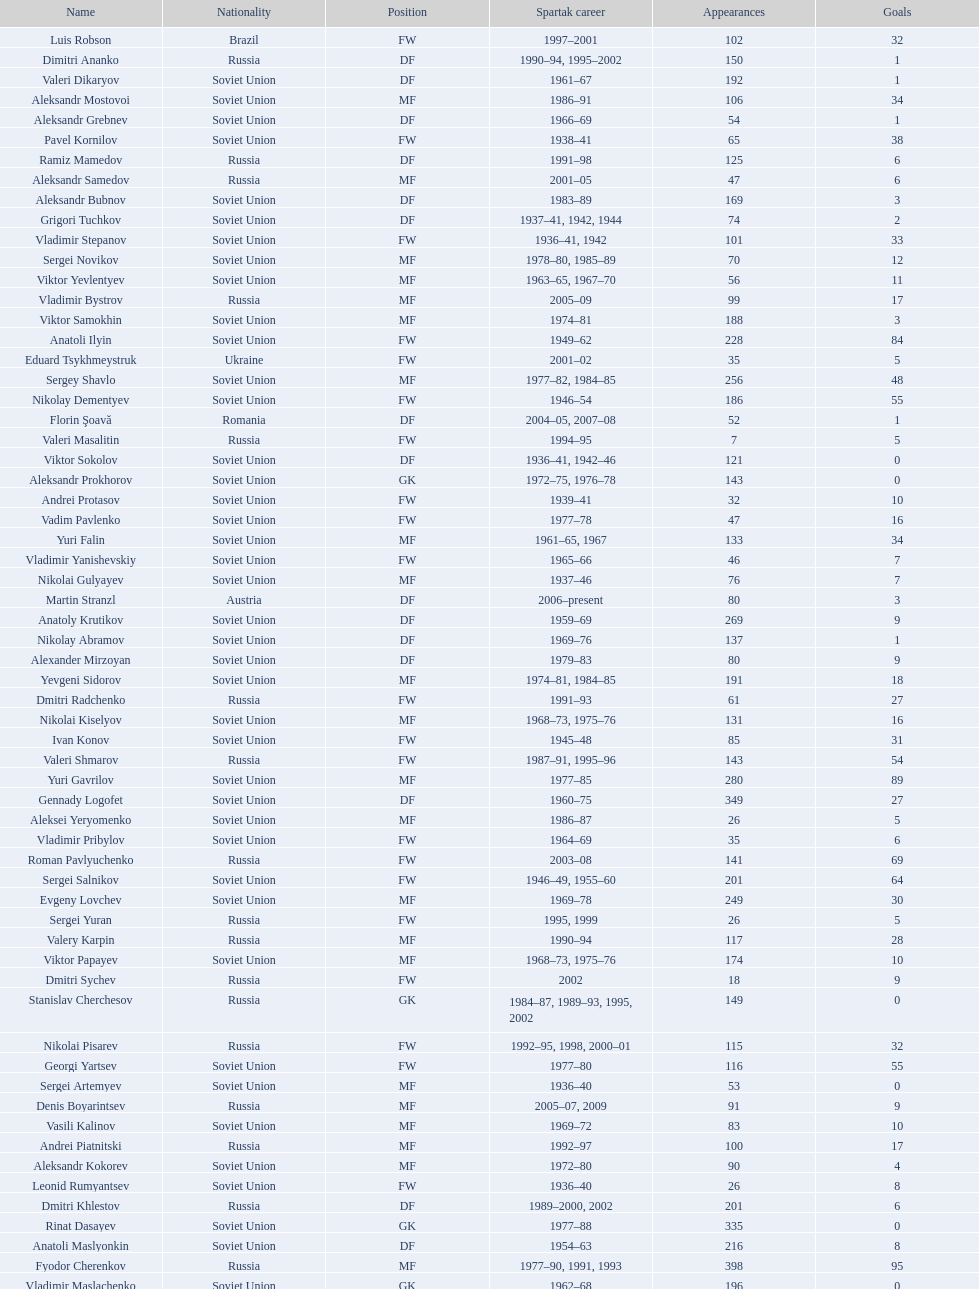Would you mind parsing the complete table? {'header': ['Name', 'Nationality', 'Position', 'Spartak career', 'Appearances', 'Goals'], 'rows': [['Luis Robson', 'Brazil', 'FW', '1997–2001', '102', '32'], ['Dimitri Ananko', 'Russia', 'DF', '1990–94, 1995–2002', '150', '1'], ['Valeri Dikaryov', 'Soviet Union', 'DF', '1961–67', '192', '1'], ['Aleksandr Mostovoi', 'Soviet Union', 'MF', '1986–91', '106', '34'], ['Aleksandr Grebnev', 'Soviet Union', 'DF', '1966–69', '54', '1'], ['Pavel Kornilov', 'Soviet Union', 'FW', '1938–41', '65', '38'], ['Ramiz Mamedov', 'Russia', 'DF', '1991–98', '125', '6'], ['Aleksandr Samedov', 'Russia', 'MF', '2001–05', '47', '6'], ['Aleksandr Bubnov', 'Soviet Union', 'DF', '1983–89', '169', '3'], ['Grigori Tuchkov', 'Soviet Union', 'DF', '1937–41, 1942, 1944', '74', '2'], ['Vladimir Stepanov', 'Soviet Union', 'FW', '1936–41, 1942', '101', '33'], ['Sergei Novikov', 'Soviet Union', 'MF', '1978–80, 1985–89', '70', '12'], ['Viktor Yevlentyev', 'Soviet Union', 'MF', '1963–65, 1967–70', '56', '11'], ['Vladimir Bystrov', 'Russia', 'MF', '2005–09', '99', '17'], ['Viktor Samokhin', 'Soviet Union', 'MF', '1974–81', '188', '3'], ['Anatoli Ilyin', 'Soviet Union', 'FW', '1949–62', '228', '84'], ['Eduard Tsykhmeystruk', 'Ukraine', 'FW', '2001–02', '35', '5'], ['Sergey Shavlo', 'Soviet Union', 'MF', '1977–82, 1984–85', '256', '48'], ['Nikolay Dementyev', 'Soviet Union', 'FW', '1946–54', '186', '55'], ['Florin Şoavă', 'Romania', 'DF', '2004–05, 2007–08', '52', '1'], ['Valeri Masalitin', 'Russia', 'FW', '1994–95', '7', '5'], ['Viktor Sokolov', 'Soviet Union', 'DF', '1936–41, 1942–46', '121', '0'], ['Aleksandr Prokhorov', 'Soviet Union', 'GK', '1972–75, 1976–78', '143', '0'], ['Andrei Protasov', 'Soviet Union', 'FW', '1939–41', '32', '10'], ['Vadim Pavlenko', 'Soviet Union', 'FW', '1977–78', '47', '16'], ['Yuri Falin', 'Soviet Union', 'MF', '1961–65, 1967', '133', '34'], ['Vladimir Yanishevskiy', 'Soviet Union', 'FW', '1965–66', '46', '7'], ['Nikolai Gulyayev', 'Soviet Union', 'MF', '1937–46', '76', '7'], ['Martin Stranzl', 'Austria', 'DF', '2006–present', '80', '3'], ['Anatoly Krutikov', 'Soviet Union', 'DF', '1959–69', '269', '9'], ['Nikolay Abramov', 'Soviet Union', 'DF', '1969–76', '137', '1'], ['Alexander Mirzoyan', 'Soviet Union', 'DF', '1979–83', '80', '9'], ['Yevgeni Sidorov', 'Soviet Union', 'MF', '1974–81, 1984–85', '191', '18'], ['Dmitri Radchenko', 'Russia', 'FW', '1991–93', '61', '27'], ['Nikolai Kiselyov', 'Soviet Union', 'MF', '1968–73, 1975–76', '131', '16'], ['Ivan Konov', 'Soviet Union', 'FW', '1945–48', '85', '31'], ['Valeri Shmarov', 'Russia', 'FW', '1987–91, 1995–96', '143', '54'], ['Yuri Gavrilov', 'Soviet Union', 'MF', '1977–85', '280', '89'], ['Gennady Logofet', 'Soviet Union', 'DF', '1960–75', '349', '27'], ['Aleksei Yeryomenko', 'Soviet Union', 'MF', '1986–87', '26', '5'], ['Vladimir Pribylov', 'Soviet Union', 'FW', '1964–69', '35', '6'], ['Roman Pavlyuchenko', 'Russia', 'FW', '2003–08', '141', '69'], ['Sergei Salnikov', 'Soviet Union', 'FW', '1946–49, 1955–60', '201', '64'], ['Evgeny Lovchev', 'Soviet Union', 'MF', '1969–78', '249', '30'], ['Sergei Yuran', 'Russia', 'FW', '1995, 1999', '26', '5'], ['Valery Karpin', 'Russia', 'MF', '1990–94', '117', '28'], ['Viktor Papayev', 'Soviet Union', 'MF', '1968–73, 1975–76', '174', '10'], ['Dmitri Sychev', 'Russia', 'FW', '2002', '18', '9'], ['Stanislav Cherchesov', 'Russia', 'GK', '1984–87, 1989–93, 1995, 2002', '149', '0'], ['Nikolai Pisarev', 'Russia', 'FW', '1992–95, 1998, 2000–01', '115', '32'], ['Georgi Yartsev', 'Soviet Union', 'FW', '1977–80', '116', '55'], ['Sergei Artemyev', 'Soviet Union', 'MF', '1936–40', '53', '0'], ['Denis Boyarintsev', 'Russia', 'MF', '2005–07, 2009', '91', '9'], ['Vasili Kalinov', 'Soviet Union', 'MF', '1969–72', '83', '10'], ['Andrei Piatnitski', 'Russia', 'MF', '1992–97', '100', '17'], ['Aleksandr Kokorev', 'Soviet Union', 'MF', '1972–80', '90', '4'], ['Leonid Rumyantsev', 'Soviet Union', 'FW', '1936–40', '26', '8'], ['Dmitri Khlestov', 'Russia', 'DF', '1989–2000, 2002', '201', '6'], ['Rinat Dasayev', 'Soviet Union', 'GK', '1977–88', '335', '0'], ['Anatoli Maslyonkin', 'Soviet Union', 'DF', '1954–63', '216', '8'], ['Fyodor Cherenkov', 'Russia', 'MF', '1977–90, 1991, 1993', '398', '95'], ['Vladimir Maslachenko', 'Soviet Union', 'GK', '1962–68', '196', '0'], ['Oleg Romantsev', 'Soviet Union', 'DF', '1976–83', '180', '6'], ['Aleksandr Shirko', 'Russia', 'FW', '1993–2001', '128', '40'], ['Boris Tatushin', 'Soviet Union', 'FW', '1953–58, 1961', '116', '38'], ['Sergei Gorlukovich', 'Russia', 'DF', '1996–98', '83', '5'], ['Radoslav Kováč', 'Czech Republic', 'MF', '2005–08', '101', '9'], ['Nikolai Tishchenko', 'Soviet Union', 'DF', '1951–58', '106', '0'], ['Vladimir Bukiyevskiy', 'Soviet Union', 'DF', '1972–79, 1982', '199', '6'], ['Ivan Mozer', 'Soviet Union', 'MF', '1956–61', '96', '30'], ['Maksym Kalynychenko', 'Ukraine', 'MF', '2000–08', '134', '22'], ['Konstantin Ryazantsev', 'Soviet Union', 'MF', '1941, 1944–51', '114', '5'], ['Sergei Rozhkov', 'Soviet Union', 'MF', '1961–65, 1967–69, 1974', '143', '8'], ['Anatoli Seglin', 'Soviet Union', 'DF', '1945–52', '83', '0'], ['Fernando Cavenaghi', 'Argentina', 'FW', '2004–06', '51', '12'], ['Oleg Timakov', 'Soviet Union', 'MF', '1945–54', '182', '19'], ['Vasili Baranov', 'Belarus', 'MF', '1998–2003', '120', '18'], ['Anatoli Akimov', 'Soviet Union', 'GK', '1936–37, 1939–41', '60', '0'], ['Yuriy Nikiforov', 'Russia', 'DF', '1993–96', '85', '16'], ['Igor Mitreski', 'Macedonia', 'DF', '2001–04', '85', '0'], ['Yuri Sevidov', 'Soviet Union', 'FW', '1960–65', '146', '54'], ['Boris Chuchelov', 'Soviet Union', 'FW', '1948', '19', '11'], ['Yuri Susloparov', 'Soviet Union', 'DF', '1986–90', '80', '1'], ['Aleksandr Piskaryov', 'Soviet Union', 'FW', '1971–75', '117', '33'], ['Vadim Evseev', 'Russia', 'DF', '1993–98, 1999', '62', '3'], ['Yevgeni Bushmanov', 'Russia', 'DF', '1989–92, 1998–2000', '58', '2'], ['Yevgeni Kuznetsov', 'Soviet Union', 'MF', '1982–89', '209', '23'], ['Sergei Olshansky', 'Soviet Union', 'DF', '1969–75', '138', '7'], ['Viktor Bulatov', 'Russia', 'MF', '1999–2001', '87', '7'], ['Vadim Ivanov', 'Soviet Union', 'DF', '1969–71', '75', '2'], ['Mikhail Bulgakov', 'Soviet Union', 'MF', '1970–79', '205', '39'], ['Gennady Morozov', 'Soviet Union', 'DF', '1980–86, 1989–90', '196', '3'], ['Viktor Onopko', 'Russia', 'DF', '1992–95', '108', '23'], ['Alex', 'Brazil', 'MF', '2009–present', '29', '12'], ['Nikita Simonyan', 'Soviet Union', 'FW', '1949–59', '215', '135'], ['Vyacheslav Ambartsumyan', 'Soviet Union', 'MF', '1959, 1963–71', '165', '31'], ['Igor Netto', 'Soviet Union', 'MF', '1949–66', '368', '36'], ['Vladimir Petrov', 'Soviet Union', 'DF', '1959–71', '174', '5'], ['Andrei Ivanov', 'Russia', 'DF', '1983–85, 1988–89, 1990–94, 1995', '109', '0'], ['Roman Shishkin', 'Russia', 'DF', '2003–08', '54', '1'], ['Aleksei Sokolov', 'Soviet Union', 'FW', '1938–41, 1942, 1944–47', '114', '49'], ['Igor Lediakhov', 'Russia', 'MF', '1992–94', '65', '21'], ['Dzhemal Silagadze', 'Soviet Union', 'FW', '1968–71, 1973', '91', '12'], ['Yuri Sedov', 'Soviet Union', 'DF', '1948–55, 1957–59', '176', '2'], ['Boris Lobutev', 'Soviet Union', 'FW', '1957–60', '15', '7'], ['Aleksandr Pavlenko', 'Russia', 'MF', '2001–07, 2008–09', '110', '11'], ['Viktor Chistyakov', 'Soviet Union', 'MF', '1957–62', '51', '3'], ['Welliton', 'Brazil', 'FW', '2007–present', '77', '51'], ['Andrejs Štolcers', 'Latvia', 'MF', '2000', '11', '5'], ['Nikita Bazhenov', 'Russia', 'FW', '2004–present', '92', '17'], ['Valentin Ivakin', 'Soviet Union', 'GK', '1957–62', '101', '0'], ['Nikolai Osyanin', 'Soviet Union', 'DF', '1966–71, 1974–76', '248', '50'], ['Aleksandr Sorokin', 'Soviet Union', 'MF', '1977–80', '107', '9'], ['Miroslav Romaschenko', 'Belarus', 'MF', '1997–98', '42', '7'], ['Stipe Pletikosa', 'Croatia', 'GK', '2007–present', '63', '0'], ['Sergei Shvetsov', 'Soviet Union', 'DF', '1981–84', '68', '14'], ['Yuri Kovtun', 'Russia', 'DF', '1999–2005', '122', '7'], ['Georgi Glazkov', 'Soviet Union', 'FW', '1936–41, 1946–47', '106', '48'], ['Galimzyan Khusainov', 'Soviet Union', 'FW', '1961–73', '346', '102'], ['Vagiz Khidiyatullin', 'Soviet Union', 'DF', '1976–80, 1986–88', '185', '22'], ['Mihajlo Pjanović', 'Serbia', 'FW', '2003–06', '48', '11'], ['Ivan Varlamov', 'Soviet Union', 'DF', '1964–68', '75', '0'], ['Anatoli Kanishchev', 'Russia', 'FW', '1998, 1999', '25', '6'], ['Boris Kuznetsov', 'Soviet Union', 'DF', '1985–88, 1989–90', '90', '0'], ['Vasili Sokolov', 'Soviet Union', 'DF', '1938–41, 1942–51', '262', '2'], ['Viktor Semyonov', 'Soviet Union', 'FW', '1937–47', '104', '49'], ['Anatoli Isayev', 'Soviet Union', 'FW', '1953–62', '159', '53'], ['Anatoli Soldatov', 'Soviet Union', 'DF', '1958–65', '113', '1'], ['Vladimir Yankin', 'Soviet Union', 'MF', '1966–70', '93', '19'], ['Valentin Yemyshev', 'Soviet Union', 'FW', '1948–53', '23', '9'], ['Yuri Syomin', 'Soviet Union', 'MF', '1965–67', '43', '6'], ['Mukhsin Mukhamadiev', 'Russia', 'MF', '1994–95', '30', '13'], ['Mozart', 'Brazil', 'MF', '2005–08', '68', '7'], ['Valeri Zenkov', 'Soviet Union', 'DF', '1971–74', '59', '1'], ['Aleksei Paramonov', 'Soviet Union', 'MF', '1947–59', '264', '61'], ['Vladimir Redin', 'Soviet Union', 'MF', '1970–74, 1976', '90', '12'], ['Nikolai Parshin', 'Soviet Union', 'FW', '1949–58', '106', '36'], ['Malik Fathi', 'Germany', 'DF', '2008–09', '37', '6'], ['Vladas Tučkus', 'Soviet Union', 'GK', '1954–57', '60', '0'], ['Ilya Tsymbalar', 'Russia', 'MF', '1993–99', '146', '42'], ['Andrey Tikhonov', 'Russia', 'MF', '1992–2000', '191', '68'], ['Clemente Rodríguez', 'Argentina', 'DF', '2004–06, 2008–09', '71', '3'], ['Viktor Pasulko', 'Soviet Union', 'MF', '1987–89', '75', '16'], ['Andrei Starostin', 'Soviet Union', 'MF', '1936–40', '95', '4'], ['Vasili Kulkov', 'Russia', 'DF', '1986, 1989–91, 1995, 1997', '93', '4'], ['Valeri Andreyev', 'Soviet Union', 'FW', '1970–76, 1977', '97', '21'], ['Valery Kechinov', 'Russia', 'MF', '1993–2000', '112', '35'], ['Yegor Titov', 'Russia', 'MF', '1992–2008', '324', '86'], ['Artyom Bezrodny', 'Russia', 'MF', '1995–97, 1998–2003', '55', '10'], ['Boris Pozdnyakov', 'Soviet Union', 'DF', '1978–84, 1989–91', '145', '3'], ['Aleksei Melyoshin', 'Russia', 'MF', '1995–2000', '68', '5'], ['Sergei Bazulev', 'Soviet Union', 'DF', '1983–84, 1989–91', '90', '0'], ['Vitali Mirzoyev', 'Soviet Union', 'FW', '1971–74', '58', '4'], ['Viktor Mishin', 'Soviet Union', 'FW', '1956–61', '43', '8'], ['Vladimir Kapustin', 'Soviet Union', 'MF', '1985–89', '51', '1'], ['Edgar Gess', 'Soviet Union', 'MF', '1979–83', '114', '26'], ['Dmitri Alenichev', 'Russia', 'MF', '1994–98, 2004–06', '143', '21'], ['Wojciech Kowalewski', 'Poland', 'GK', '2003–07', '94', '0'], ['Maksim Buznikin', 'Russia', 'FW', '1997–99, 2000', '55', '18'], ['Igor Shalimov', 'Russia', 'MF', '1986–91', '95', '20'], ['Hennadiy Perepadenko', 'Ukraine', 'MF', '1990–91, 1992', '51', '6'], ['Valeri Reyngold', 'Soviet Union', 'FW', '1960–67', '176', '32'], ['Aleksandr Minayev', 'Soviet Union', 'MF', '1972–75', '92', '10'], ['Aleksandr Kalashnikov', 'Soviet Union', 'FW', '1978–82', '67', '16'], ['Vladimir Beschastnykh', 'Russia', 'FW', '1991–94, 2001–02', '104', '56'], ['Vladimir Chernyshev', 'Soviet Union', 'GK', '1946–55', '74', '0'], ['Aleksandr Rystsov', 'Soviet Union', 'FW', '1947–54', '100', '16'], ['Anzor Kavazashvili', 'Soviet Union', 'GK', '1969–71', '74', '0'], ['Aleksandr Filimonov', 'Russia', 'GK', '1996–2001', '147', '0'], ['Valeri Gladilin', 'Soviet Union', 'MF', '1974–78, 1983–84', '169', '28'], ['Andrei Rudakov', 'Soviet Union', 'FW', '1985–87', '49', '17'], ['Viktor Konovalov', 'Soviet Union', 'MF', '1960–61', '24', '5'], ['Aleksei Leontyev', 'Soviet Union', 'GK', '1940–49', '109', '0'], ['Alexey Korneyev', 'Soviet Union', 'DF', '1957–67', '177', '0'], ['Dmitri Popov', 'Russia', 'DF', '1989–93', '78', '7'], ['Vladimir Nikonov', 'Soviet Union', 'MF', '1979–80, 1982', '25', '5'], ['Konstantin Malinin', 'Soviet Union', 'DF', '1939–50', '140', '7'], ['Mikhail Rusyayev', 'Russia', 'FW', '1981–87, 1992', '47', '9'], ['Viktor Terentyev', 'Soviet Union', 'FW', '1948–53', '103', '34'], ['Sergey Rodionov', 'Russia', 'FW', '1979–90, 1993–95', '303', '124'], ['Dmytro Parfenov', 'Ukraine', 'DF', '1998–2005', '125', '15'], ['Mikhail Ogonkov', 'Soviet Union', 'DF', '1953–58, 1961', '78', '0'], ['Vladimir Sochnov', 'Soviet Union', 'DF', '1981–85, 1989', '148', '9'], ['Dmitri Kudryashov', 'Russia', 'MF', '2002', '22', '5'], ['Martin Jiránek', 'Czech Republic', 'DF', '2004–present', '126', '3'], ['Serafim Kholodkov', 'Soviet Union', 'DF', '1941, 1946–49', '90', '0'], ['Serghei Covalciuc', 'Moldova', 'MF', '2004–09', '90', '2'], ['Boris Petrov', 'Soviet Union', 'FW', '1962', '18', '5'], ['Boris Smyslov', 'Soviet Union', 'FW', '1945–48', '45', '6']]} Name two players with goals above 15. Dmitri Alenichev, Vyacheslav Ambartsumyan. 